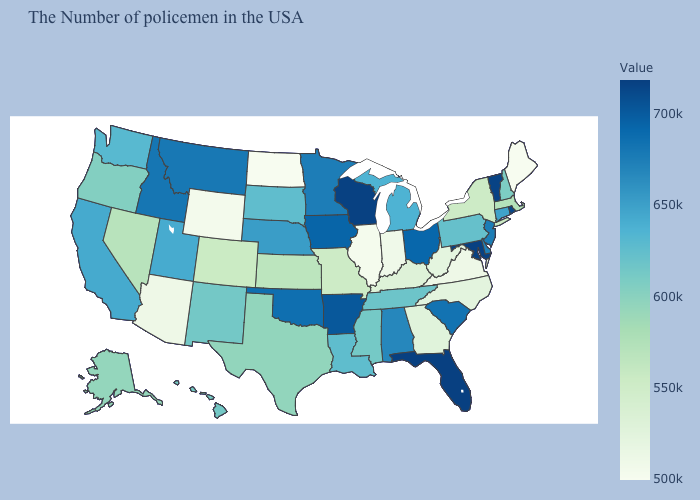Does Idaho have the lowest value in the West?
Write a very short answer. No. Which states have the highest value in the USA?
Keep it brief. Florida. Among the states that border Washington , does Idaho have the highest value?
Quick response, please. Yes. Does Louisiana have the lowest value in the USA?
Give a very brief answer. No. Which states have the lowest value in the South?
Write a very short answer. Virginia. Does Wisconsin have the lowest value in the USA?
Be succinct. No. Does the map have missing data?
Short answer required. No. Does the map have missing data?
Write a very short answer. No. 